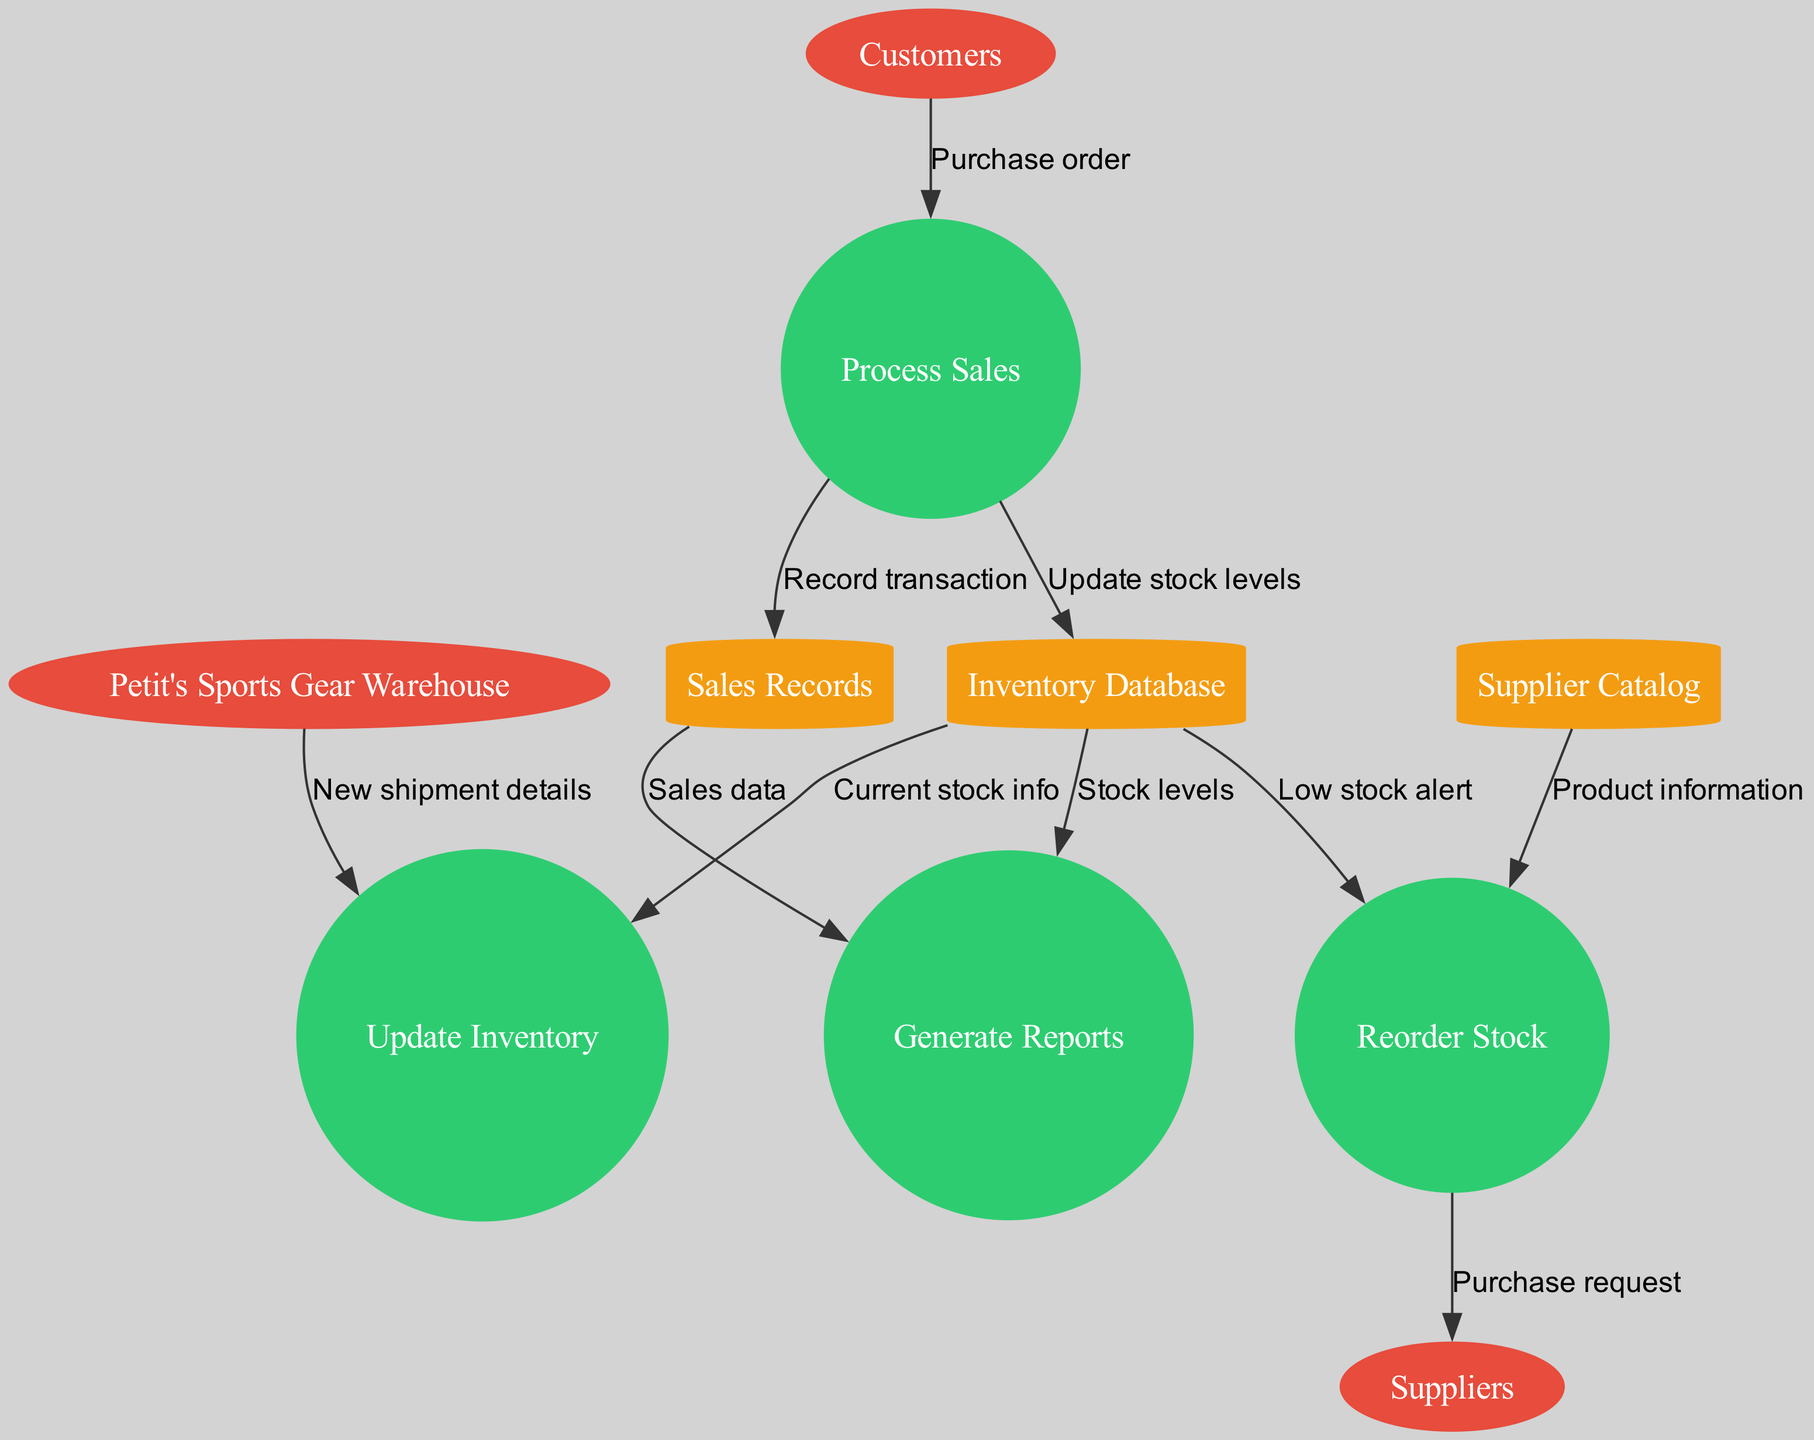What is the total number of external entities in the diagram? The diagram lists three external entities: Customers, Suppliers, and Petit's Sports Gear Warehouse. Counting these gives us a total of three.
Answer: 3 Which process records transactions? The diagram indicates that the "Process Sales" process handles the recording of transactions. This is shown by the flow from "Process Sales" to "Sales Records" labeled as "Record transaction."
Answer: Process Sales What data flow comes from Petit’s Sports Gear Warehouse? According to the diagram, there is a data flow labeled "New shipment details" that originates from "Petit's Sports Gear Warehouse" and flows into the "Update Inventory" process.
Answer: New shipment details How many data stores are in the diagram? The diagram contains three data stores: Inventory Database, Sales Records, and Supplier Catalog. Adding these together results in three data stores.
Answer: 3 What is triggered by a low stock alert? The "Reorder Stock" process is triggered by a low stock alert, which is indicated by the flow from "Inventory Database" to "Reorder Stock" labeled as "Low stock alert."
Answer: Reorder Stock Which external entity receives purchase requests? The diagram shows that the "Reorder Stock" process sends purchase requests to the "Suppliers" external entity. This relationship is defined by the flow labeled "Purchase request."
Answer: Suppliers What type of data is generated by the "Generate Reports" process? The "Generate Reports" process generates reports using two types of data: "Sales data" from "Sales Records" and "Stock levels" from "Inventory Database." Thus, the data generated relates to sales and stock levels.
Answer: Sales data and Stock levels What process updates stock levels in the Inventory Database? The "Process Sales" process is responsible for updating stock levels in the Inventory Database as indicated by the flow labeled "Update stock levels."
Answer: Update stock levels Which node does the "Purchase order" flow into? The "Purchase order" flow enters the "Process Sales" process as indicated by the connection between "Customers" and "Process Sales."
Answer: Process Sales 